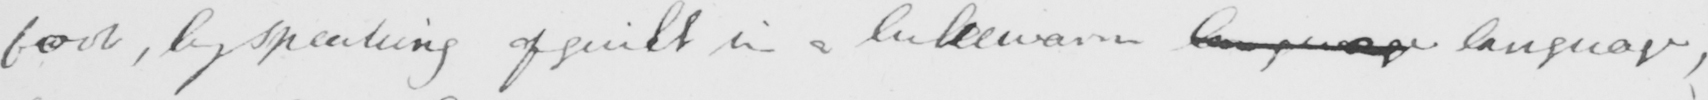Please provide the text content of this handwritten line. foot , by speaking of guilt in a lukewarm language language , 